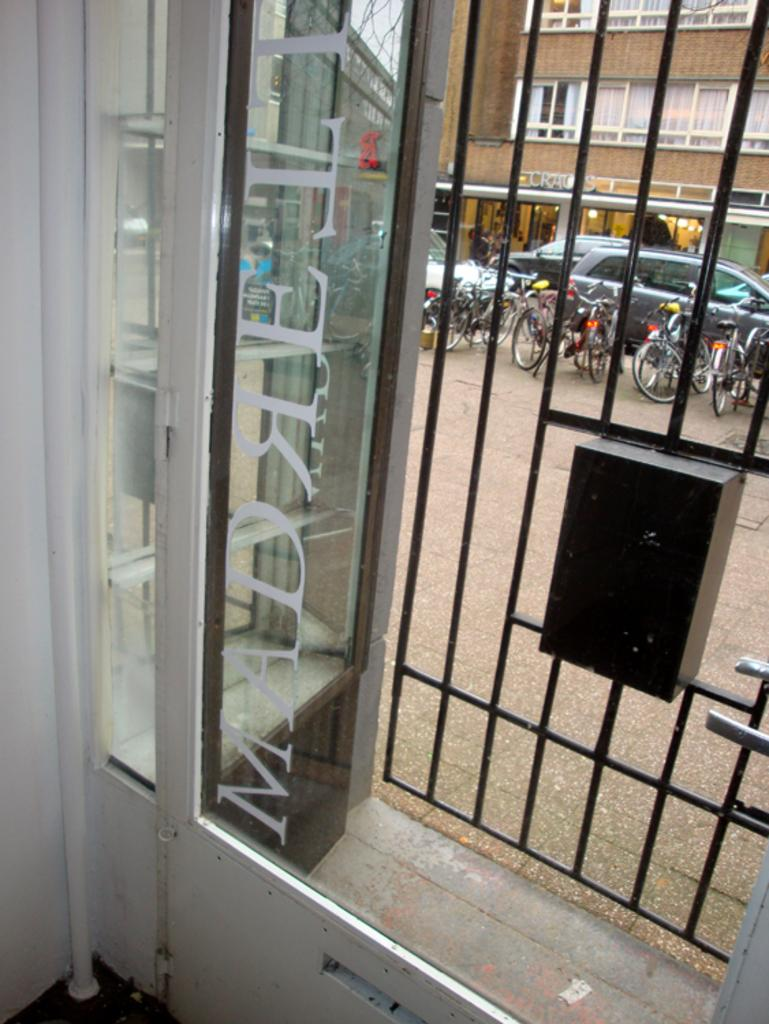What is the main object in the image? There is a box in the image. What can be seen through the window in the image? Vehicles and bicycles are visible from the window. What is visible in the background of the image? Buildings, lights, and some unspecified objects are visible in the background of the image. Who is the daughter of the person standing next to the box in the image? There is no person standing next to the box in the image, and therefore no daughter is mentioned or depicted. 